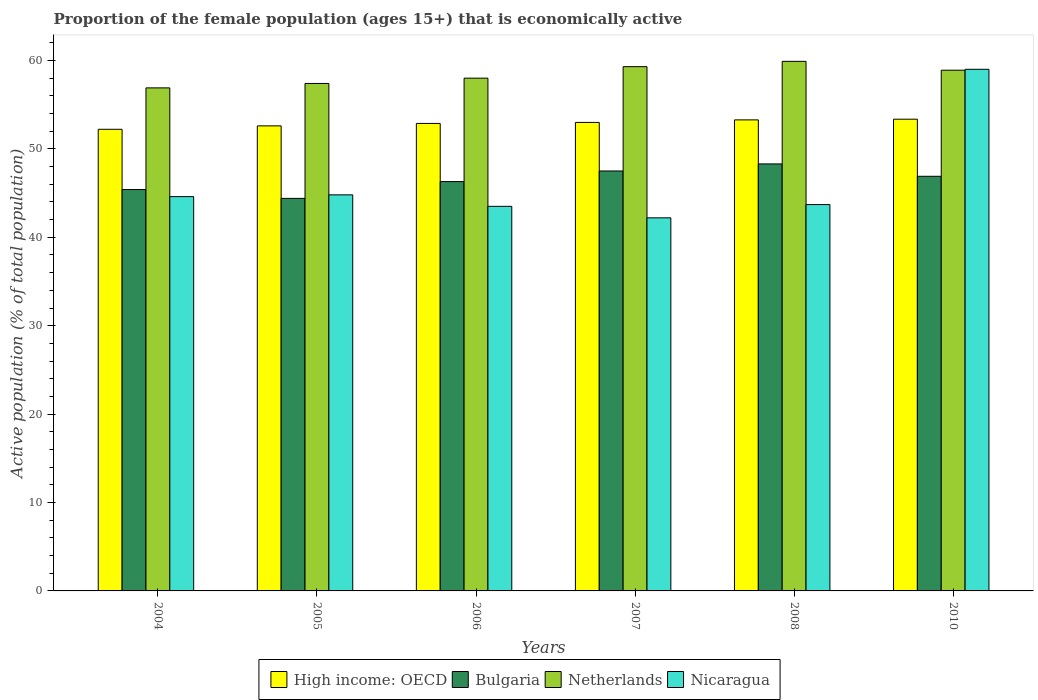How many different coloured bars are there?
Ensure brevity in your answer.  4. How many groups of bars are there?
Ensure brevity in your answer.  6. Are the number of bars per tick equal to the number of legend labels?
Give a very brief answer. Yes. How many bars are there on the 5th tick from the left?
Provide a succinct answer. 4. What is the label of the 5th group of bars from the left?
Your answer should be very brief. 2008. What is the proportion of the female population that is economically active in Nicaragua in 2006?
Offer a very short reply. 43.5. Across all years, what is the maximum proportion of the female population that is economically active in Netherlands?
Offer a very short reply. 59.9. Across all years, what is the minimum proportion of the female population that is economically active in High income: OECD?
Your answer should be very brief. 52.22. In which year was the proportion of the female population that is economically active in High income: OECD minimum?
Your answer should be compact. 2004. What is the total proportion of the female population that is economically active in Bulgaria in the graph?
Provide a succinct answer. 278.8. What is the difference between the proportion of the female population that is economically active in Nicaragua in 2005 and that in 2006?
Ensure brevity in your answer.  1.3. What is the difference between the proportion of the female population that is economically active in Netherlands in 2007 and the proportion of the female population that is economically active in Bulgaria in 2010?
Offer a very short reply. 12.4. What is the average proportion of the female population that is economically active in High income: OECD per year?
Your response must be concise. 52.89. In the year 2007, what is the difference between the proportion of the female population that is economically active in Bulgaria and proportion of the female population that is economically active in Nicaragua?
Offer a terse response. 5.3. What is the ratio of the proportion of the female population that is economically active in Netherlands in 2007 to that in 2008?
Offer a very short reply. 0.99. Is the difference between the proportion of the female population that is economically active in Bulgaria in 2007 and 2010 greater than the difference between the proportion of the female population that is economically active in Nicaragua in 2007 and 2010?
Your answer should be very brief. Yes. What is the difference between the highest and the second highest proportion of the female population that is economically active in Bulgaria?
Provide a succinct answer. 0.8. What is the difference between the highest and the lowest proportion of the female population that is economically active in Netherlands?
Your answer should be very brief. 3. Is it the case that in every year, the sum of the proportion of the female population that is economically active in High income: OECD and proportion of the female population that is economically active in Bulgaria is greater than the sum of proportion of the female population that is economically active in Nicaragua and proportion of the female population that is economically active in Netherlands?
Your answer should be very brief. No. What does the 3rd bar from the right in 2007 represents?
Keep it short and to the point. Bulgaria. Are all the bars in the graph horizontal?
Provide a short and direct response. No. How many years are there in the graph?
Ensure brevity in your answer.  6. What is the difference between two consecutive major ticks on the Y-axis?
Ensure brevity in your answer.  10. Are the values on the major ticks of Y-axis written in scientific E-notation?
Make the answer very short. No. Where does the legend appear in the graph?
Offer a terse response. Bottom center. How are the legend labels stacked?
Provide a succinct answer. Horizontal. What is the title of the graph?
Provide a succinct answer. Proportion of the female population (ages 15+) that is economically active. What is the label or title of the X-axis?
Provide a succinct answer. Years. What is the label or title of the Y-axis?
Your answer should be very brief. Active population (% of total population). What is the Active population (% of total population) of High income: OECD in 2004?
Ensure brevity in your answer.  52.22. What is the Active population (% of total population) of Bulgaria in 2004?
Offer a terse response. 45.4. What is the Active population (% of total population) in Netherlands in 2004?
Your response must be concise. 56.9. What is the Active population (% of total population) of Nicaragua in 2004?
Keep it short and to the point. 44.6. What is the Active population (% of total population) in High income: OECD in 2005?
Ensure brevity in your answer.  52.6. What is the Active population (% of total population) in Bulgaria in 2005?
Ensure brevity in your answer.  44.4. What is the Active population (% of total population) of Netherlands in 2005?
Make the answer very short. 57.4. What is the Active population (% of total population) in Nicaragua in 2005?
Provide a short and direct response. 44.8. What is the Active population (% of total population) of High income: OECD in 2006?
Your response must be concise. 52.88. What is the Active population (% of total population) of Bulgaria in 2006?
Make the answer very short. 46.3. What is the Active population (% of total population) of Nicaragua in 2006?
Your answer should be compact. 43.5. What is the Active population (% of total population) of High income: OECD in 2007?
Give a very brief answer. 52.99. What is the Active population (% of total population) in Bulgaria in 2007?
Your answer should be very brief. 47.5. What is the Active population (% of total population) of Netherlands in 2007?
Make the answer very short. 59.3. What is the Active population (% of total population) in Nicaragua in 2007?
Make the answer very short. 42.2. What is the Active population (% of total population) in High income: OECD in 2008?
Keep it short and to the point. 53.28. What is the Active population (% of total population) of Bulgaria in 2008?
Make the answer very short. 48.3. What is the Active population (% of total population) of Netherlands in 2008?
Your response must be concise. 59.9. What is the Active population (% of total population) in Nicaragua in 2008?
Your answer should be very brief. 43.7. What is the Active population (% of total population) of High income: OECD in 2010?
Ensure brevity in your answer.  53.36. What is the Active population (% of total population) of Bulgaria in 2010?
Your response must be concise. 46.9. What is the Active population (% of total population) in Netherlands in 2010?
Ensure brevity in your answer.  58.9. What is the Active population (% of total population) in Nicaragua in 2010?
Your answer should be compact. 59. Across all years, what is the maximum Active population (% of total population) of High income: OECD?
Ensure brevity in your answer.  53.36. Across all years, what is the maximum Active population (% of total population) in Bulgaria?
Offer a terse response. 48.3. Across all years, what is the maximum Active population (% of total population) in Netherlands?
Your response must be concise. 59.9. Across all years, what is the maximum Active population (% of total population) of Nicaragua?
Your response must be concise. 59. Across all years, what is the minimum Active population (% of total population) in High income: OECD?
Offer a terse response. 52.22. Across all years, what is the minimum Active population (% of total population) of Bulgaria?
Provide a succinct answer. 44.4. Across all years, what is the minimum Active population (% of total population) of Netherlands?
Offer a very short reply. 56.9. Across all years, what is the minimum Active population (% of total population) of Nicaragua?
Your answer should be very brief. 42.2. What is the total Active population (% of total population) of High income: OECD in the graph?
Your answer should be very brief. 317.33. What is the total Active population (% of total population) of Bulgaria in the graph?
Offer a very short reply. 278.8. What is the total Active population (% of total population) in Netherlands in the graph?
Make the answer very short. 350.4. What is the total Active population (% of total population) of Nicaragua in the graph?
Your response must be concise. 277.8. What is the difference between the Active population (% of total population) in High income: OECD in 2004 and that in 2005?
Offer a very short reply. -0.39. What is the difference between the Active population (% of total population) in Netherlands in 2004 and that in 2005?
Give a very brief answer. -0.5. What is the difference between the Active population (% of total population) of Nicaragua in 2004 and that in 2005?
Ensure brevity in your answer.  -0.2. What is the difference between the Active population (% of total population) in High income: OECD in 2004 and that in 2006?
Your answer should be very brief. -0.66. What is the difference between the Active population (% of total population) in Netherlands in 2004 and that in 2006?
Your answer should be compact. -1.1. What is the difference between the Active population (% of total population) in Nicaragua in 2004 and that in 2006?
Your answer should be very brief. 1.1. What is the difference between the Active population (% of total population) of High income: OECD in 2004 and that in 2007?
Your answer should be very brief. -0.78. What is the difference between the Active population (% of total population) in Bulgaria in 2004 and that in 2007?
Ensure brevity in your answer.  -2.1. What is the difference between the Active population (% of total population) of Netherlands in 2004 and that in 2007?
Keep it short and to the point. -2.4. What is the difference between the Active population (% of total population) of Nicaragua in 2004 and that in 2007?
Your response must be concise. 2.4. What is the difference between the Active population (% of total population) of High income: OECD in 2004 and that in 2008?
Your answer should be compact. -1.06. What is the difference between the Active population (% of total population) of Bulgaria in 2004 and that in 2008?
Provide a short and direct response. -2.9. What is the difference between the Active population (% of total population) of High income: OECD in 2004 and that in 2010?
Ensure brevity in your answer.  -1.14. What is the difference between the Active population (% of total population) of Bulgaria in 2004 and that in 2010?
Offer a very short reply. -1.5. What is the difference between the Active population (% of total population) in Netherlands in 2004 and that in 2010?
Offer a very short reply. -2. What is the difference between the Active population (% of total population) of Nicaragua in 2004 and that in 2010?
Ensure brevity in your answer.  -14.4. What is the difference between the Active population (% of total population) of High income: OECD in 2005 and that in 2006?
Offer a very short reply. -0.27. What is the difference between the Active population (% of total population) in Bulgaria in 2005 and that in 2006?
Offer a very short reply. -1.9. What is the difference between the Active population (% of total population) in Netherlands in 2005 and that in 2006?
Ensure brevity in your answer.  -0.6. What is the difference between the Active population (% of total population) in Nicaragua in 2005 and that in 2006?
Ensure brevity in your answer.  1.3. What is the difference between the Active population (% of total population) of High income: OECD in 2005 and that in 2007?
Make the answer very short. -0.39. What is the difference between the Active population (% of total population) in Netherlands in 2005 and that in 2007?
Ensure brevity in your answer.  -1.9. What is the difference between the Active population (% of total population) of High income: OECD in 2005 and that in 2008?
Make the answer very short. -0.68. What is the difference between the Active population (% of total population) of Netherlands in 2005 and that in 2008?
Make the answer very short. -2.5. What is the difference between the Active population (% of total population) in Nicaragua in 2005 and that in 2008?
Provide a succinct answer. 1.1. What is the difference between the Active population (% of total population) of High income: OECD in 2005 and that in 2010?
Give a very brief answer. -0.76. What is the difference between the Active population (% of total population) of Netherlands in 2005 and that in 2010?
Provide a succinct answer. -1.5. What is the difference between the Active population (% of total population) in Nicaragua in 2005 and that in 2010?
Make the answer very short. -14.2. What is the difference between the Active population (% of total population) in High income: OECD in 2006 and that in 2007?
Your answer should be very brief. -0.11. What is the difference between the Active population (% of total population) in Bulgaria in 2006 and that in 2007?
Offer a terse response. -1.2. What is the difference between the Active population (% of total population) of Nicaragua in 2006 and that in 2007?
Provide a short and direct response. 1.3. What is the difference between the Active population (% of total population) of High income: OECD in 2006 and that in 2008?
Keep it short and to the point. -0.4. What is the difference between the Active population (% of total population) of Bulgaria in 2006 and that in 2008?
Your answer should be very brief. -2. What is the difference between the Active population (% of total population) in Nicaragua in 2006 and that in 2008?
Your response must be concise. -0.2. What is the difference between the Active population (% of total population) in High income: OECD in 2006 and that in 2010?
Make the answer very short. -0.48. What is the difference between the Active population (% of total population) in Bulgaria in 2006 and that in 2010?
Offer a very short reply. -0.6. What is the difference between the Active population (% of total population) of Netherlands in 2006 and that in 2010?
Make the answer very short. -0.9. What is the difference between the Active population (% of total population) of Nicaragua in 2006 and that in 2010?
Give a very brief answer. -15.5. What is the difference between the Active population (% of total population) of High income: OECD in 2007 and that in 2008?
Provide a succinct answer. -0.29. What is the difference between the Active population (% of total population) of Netherlands in 2007 and that in 2008?
Your response must be concise. -0.6. What is the difference between the Active population (% of total population) in Nicaragua in 2007 and that in 2008?
Offer a terse response. -1.5. What is the difference between the Active population (% of total population) in High income: OECD in 2007 and that in 2010?
Keep it short and to the point. -0.37. What is the difference between the Active population (% of total population) of Nicaragua in 2007 and that in 2010?
Provide a short and direct response. -16.8. What is the difference between the Active population (% of total population) in High income: OECD in 2008 and that in 2010?
Keep it short and to the point. -0.08. What is the difference between the Active population (% of total population) of Bulgaria in 2008 and that in 2010?
Make the answer very short. 1.4. What is the difference between the Active population (% of total population) of Nicaragua in 2008 and that in 2010?
Make the answer very short. -15.3. What is the difference between the Active population (% of total population) in High income: OECD in 2004 and the Active population (% of total population) in Bulgaria in 2005?
Give a very brief answer. 7.82. What is the difference between the Active population (% of total population) in High income: OECD in 2004 and the Active population (% of total population) in Netherlands in 2005?
Offer a very short reply. -5.18. What is the difference between the Active population (% of total population) of High income: OECD in 2004 and the Active population (% of total population) of Nicaragua in 2005?
Ensure brevity in your answer.  7.42. What is the difference between the Active population (% of total population) in Bulgaria in 2004 and the Active population (% of total population) in Netherlands in 2005?
Ensure brevity in your answer.  -12. What is the difference between the Active population (% of total population) of High income: OECD in 2004 and the Active population (% of total population) of Bulgaria in 2006?
Make the answer very short. 5.92. What is the difference between the Active population (% of total population) of High income: OECD in 2004 and the Active population (% of total population) of Netherlands in 2006?
Give a very brief answer. -5.78. What is the difference between the Active population (% of total population) of High income: OECD in 2004 and the Active population (% of total population) of Nicaragua in 2006?
Make the answer very short. 8.72. What is the difference between the Active population (% of total population) in Bulgaria in 2004 and the Active population (% of total population) in Nicaragua in 2006?
Offer a very short reply. 1.9. What is the difference between the Active population (% of total population) in High income: OECD in 2004 and the Active population (% of total population) in Bulgaria in 2007?
Provide a short and direct response. 4.72. What is the difference between the Active population (% of total population) of High income: OECD in 2004 and the Active population (% of total population) of Netherlands in 2007?
Make the answer very short. -7.08. What is the difference between the Active population (% of total population) in High income: OECD in 2004 and the Active population (% of total population) in Nicaragua in 2007?
Offer a very short reply. 10.02. What is the difference between the Active population (% of total population) of Bulgaria in 2004 and the Active population (% of total population) of Nicaragua in 2007?
Your answer should be compact. 3.2. What is the difference between the Active population (% of total population) in High income: OECD in 2004 and the Active population (% of total population) in Bulgaria in 2008?
Your answer should be very brief. 3.92. What is the difference between the Active population (% of total population) of High income: OECD in 2004 and the Active population (% of total population) of Netherlands in 2008?
Make the answer very short. -7.68. What is the difference between the Active population (% of total population) of High income: OECD in 2004 and the Active population (% of total population) of Nicaragua in 2008?
Give a very brief answer. 8.52. What is the difference between the Active population (% of total population) in High income: OECD in 2004 and the Active population (% of total population) in Bulgaria in 2010?
Give a very brief answer. 5.32. What is the difference between the Active population (% of total population) of High income: OECD in 2004 and the Active population (% of total population) of Netherlands in 2010?
Your answer should be very brief. -6.68. What is the difference between the Active population (% of total population) in High income: OECD in 2004 and the Active population (% of total population) in Nicaragua in 2010?
Ensure brevity in your answer.  -6.78. What is the difference between the Active population (% of total population) in Bulgaria in 2004 and the Active population (% of total population) in Nicaragua in 2010?
Provide a short and direct response. -13.6. What is the difference between the Active population (% of total population) in High income: OECD in 2005 and the Active population (% of total population) in Bulgaria in 2006?
Your answer should be very brief. 6.3. What is the difference between the Active population (% of total population) of High income: OECD in 2005 and the Active population (% of total population) of Netherlands in 2006?
Give a very brief answer. -5.4. What is the difference between the Active population (% of total population) of High income: OECD in 2005 and the Active population (% of total population) of Nicaragua in 2006?
Your answer should be compact. 9.1. What is the difference between the Active population (% of total population) in Bulgaria in 2005 and the Active population (% of total population) in Netherlands in 2006?
Keep it short and to the point. -13.6. What is the difference between the Active population (% of total population) of Bulgaria in 2005 and the Active population (% of total population) of Nicaragua in 2006?
Offer a terse response. 0.9. What is the difference between the Active population (% of total population) in High income: OECD in 2005 and the Active population (% of total population) in Bulgaria in 2007?
Provide a succinct answer. 5.1. What is the difference between the Active population (% of total population) in High income: OECD in 2005 and the Active population (% of total population) in Netherlands in 2007?
Keep it short and to the point. -6.7. What is the difference between the Active population (% of total population) of High income: OECD in 2005 and the Active population (% of total population) of Nicaragua in 2007?
Offer a very short reply. 10.4. What is the difference between the Active population (% of total population) in Bulgaria in 2005 and the Active population (% of total population) in Netherlands in 2007?
Give a very brief answer. -14.9. What is the difference between the Active population (% of total population) in Bulgaria in 2005 and the Active population (% of total population) in Nicaragua in 2007?
Provide a succinct answer. 2.2. What is the difference between the Active population (% of total population) of High income: OECD in 2005 and the Active population (% of total population) of Bulgaria in 2008?
Your answer should be compact. 4.3. What is the difference between the Active population (% of total population) of High income: OECD in 2005 and the Active population (% of total population) of Netherlands in 2008?
Your response must be concise. -7.3. What is the difference between the Active population (% of total population) of High income: OECD in 2005 and the Active population (% of total population) of Nicaragua in 2008?
Offer a very short reply. 8.9. What is the difference between the Active population (% of total population) of Bulgaria in 2005 and the Active population (% of total population) of Netherlands in 2008?
Your answer should be very brief. -15.5. What is the difference between the Active population (% of total population) in Netherlands in 2005 and the Active population (% of total population) in Nicaragua in 2008?
Keep it short and to the point. 13.7. What is the difference between the Active population (% of total population) of High income: OECD in 2005 and the Active population (% of total population) of Bulgaria in 2010?
Give a very brief answer. 5.7. What is the difference between the Active population (% of total population) in High income: OECD in 2005 and the Active population (% of total population) in Netherlands in 2010?
Keep it short and to the point. -6.3. What is the difference between the Active population (% of total population) of High income: OECD in 2005 and the Active population (% of total population) of Nicaragua in 2010?
Keep it short and to the point. -6.4. What is the difference between the Active population (% of total population) of Bulgaria in 2005 and the Active population (% of total population) of Nicaragua in 2010?
Your response must be concise. -14.6. What is the difference between the Active population (% of total population) in High income: OECD in 2006 and the Active population (% of total population) in Bulgaria in 2007?
Your answer should be compact. 5.38. What is the difference between the Active population (% of total population) in High income: OECD in 2006 and the Active population (% of total population) in Netherlands in 2007?
Your answer should be compact. -6.42. What is the difference between the Active population (% of total population) of High income: OECD in 2006 and the Active population (% of total population) of Nicaragua in 2007?
Provide a short and direct response. 10.68. What is the difference between the Active population (% of total population) in Bulgaria in 2006 and the Active population (% of total population) in Nicaragua in 2007?
Offer a very short reply. 4.1. What is the difference between the Active population (% of total population) in Netherlands in 2006 and the Active population (% of total population) in Nicaragua in 2007?
Your answer should be very brief. 15.8. What is the difference between the Active population (% of total population) in High income: OECD in 2006 and the Active population (% of total population) in Bulgaria in 2008?
Provide a short and direct response. 4.58. What is the difference between the Active population (% of total population) in High income: OECD in 2006 and the Active population (% of total population) in Netherlands in 2008?
Your response must be concise. -7.02. What is the difference between the Active population (% of total population) of High income: OECD in 2006 and the Active population (% of total population) of Nicaragua in 2008?
Offer a very short reply. 9.18. What is the difference between the Active population (% of total population) of Bulgaria in 2006 and the Active population (% of total population) of Netherlands in 2008?
Provide a succinct answer. -13.6. What is the difference between the Active population (% of total population) in Bulgaria in 2006 and the Active population (% of total population) in Nicaragua in 2008?
Your answer should be compact. 2.6. What is the difference between the Active population (% of total population) of High income: OECD in 2006 and the Active population (% of total population) of Bulgaria in 2010?
Keep it short and to the point. 5.98. What is the difference between the Active population (% of total population) in High income: OECD in 2006 and the Active population (% of total population) in Netherlands in 2010?
Your response must be concise. -6.02. What is the difference between the Active population (% of total population) of High income: OECD in 2006 and the Active population (% of total population) of Nicaragua in 2010?
Ensure brevity in your answer.  -6.12. What is the difference between the Active population (% of total population) of Bulgaria in 2006 and the Active population (% of total population) of Netherlands in 2010?
Give a very brief answer. -12.6. What is the difference between the Active population (% of total population) in Netherlands in 2006 and the Active population (% of total population) in Nicaragua in 2010?
Your answer should be compact. -1. What is the difference between the Active population (% of total population) of High income: OECD in 2007 and the Active population (% of total population) of Bulgaria in 2008?
Keep it short and to the point. 4.69. What is the difference between the Active population (% of total population) of High income: OECD in 2007 and the Active population (% of total population) of Netherlands in 2008?
Provide a short and direct response. -6.91. What is the difference between the Active population (% of total population) in High income: OECD in 2007 and the Active population (% of total population) in Nicaragua in 2008?
Offer a terse response. 9.29. What is the difference between the Active population (% of total population) in Bulgaria in 2007 and the Active population (% of total population) in Nicaragua in 2008?
Offer a terse response. 3.8. What is the difference between the Active population (% of total population) of High income: OECD in 2007 and the Active population (% of total population) of Bulgaria in 2010?
Make the answer very short. 6.09. What is the difference between the Active population (% of total population) in High income: OECD in 2007 and the Active population (% of total population) in Netherlands in 2010?
Ensure brevity in your answer.  -5.91. What is the difference between the Active population (% of total population) of High income: OECD in 2007 and the Active population (% of total population) of Nicaragua in 2010?
Keep it short and to the point. -6.01. What is the difference between the Active population (% of total population) of Netherlands in 2007 and the Active population (% of total population) of Nicaragua in 2010?
Offer a very short reply. 0.3. What is the difference between the Active population (% of total population) of High income: OECD in 2008 and the Active population (% of total population) of Bulgaria in 2010?
Provide a short and direct response. 6.38. What is the difference between the Active population (% of total population) in High income: OECD in 2008 and the Active population (% of total population) in Netherlands in 2010?
Offer a very short reply. -5.62. What is the difference between the Active population (% of total population) in High income: OECD in 2008 and the Active population (% of total population) in Nicaragua in 2010?
Offer a very short reply. -5.72. What is the difference between the Active population (% of total population) in Bulgaria in 2008 and the Active population (% of total population) in Nicaragua in 2010?
Provide a short and direct response. -10.7. What is the difference between the Active population (% of total population) of Netherlands in 2008 and the Active population (% of total population) of Nicaragua in 2010?
Your answer should be very brief. 0.9. What is the average Active population (% of total population) in High income: OECD per year?
Your answer should be compact. 52.89. What is the average Active population (% of total population) in Bulgaria per year?
Give a very brief answer. 46.47. What is the average Active population (% of total population) of Netherlands per year?
Make the answer very short. 58.4. What is the average Active population (% of total population) of Nicaragua per year?
Offer a terse response. 46.3. In the year 2004, what is the difference between the Active population (% of total population) in High income: OECD and Active population (% of total population) in Bulgaria?
Ensure brevity in your answer.  6.82. In the year 2004, what is the difference between the Active population (% of total population) in High income: OECD and Active population (% of total population) in Netherlands?
Provide a succinct answer. -4.68. In the year 2004, what is the difference between the Active population (% of total population) of High income: OECD and Active population (% of total population) of Nicaragua?
Provide a succinct answer. 7.62. In the year 2004, what is the difference between the Active population (% of total population) in Bulgaria and Active population (% of total population) in Nicaragua?
Offer a terse response. 0.8. In the year 2004, what is the difference between the Active population (% of total population) of Netherlands and Active population (% of total population) of Nicaragua?
Give a very brief answer. 12.3. In the year 2005, what is the difference between the Active population (% of total population) of High income: OECD and Active population (% of total population) of Bulgaria?
Keep it short and to the point. 8.2. In the year 2005, what is the difference between the Active population (% of total population) in High income: OECD and Active population (% of total population) in Netherlands?
Provide a short and direct response. -4.8. In the year 2005, what is the difference between the Active population (% of total population) in High income: OECD and Active population (% of total population) in Nicaragua?
Ensure brevity in your answer.  7.8. In the year 2005, what is the difference between the Active population (% of total population) in Bulgaria and Active population (% of total population) in Netherlands?
Make the answer very short. -13. In the year 2005, what is the difference between the Active population (% of total population) in Netherlands and Active population (% of total population) in Nicaragua?
Offer a very short reply. 12.6. In the year 2006, what is the difference between the Active population (% of total population) in High income: OECD and Active population (% of total population) in Bulgaria?
Provide a short and direct response. 6.58. In the year 2006, what is the difference between the Active population (% of total population) in High income: OECD and Active population (% of total population) in Netherlands?
Offer a terse response. -5.12. In the year 2006, what is the difference between the Active population (% of total population) of High income: OECD and Active population (% of total population) of Nicaragua?
Offer a very short reply. 9.38. In the year 2006, what is the difference between the Active population (% of total population) of Bulgaria and Active population (% of total population) of Nicaragua?
Offer a terse response. 2.8. In the year 2007, what is the difference between the Active population (% of total population) of High income: OECD and Active population (% of total population) of Bulgaria?
Make the answer very short. 5.49. In the year 2007, what is the difference between the Active population (% of total population) in High income: OECD and Active population (% of total population) in Netherlands?
Provide a short and direct response. -6.31. In the year 2007, what is the difference between the Active population (% of total population) of High income: OECD and Active population (% of total population) of Nicaragua?
Provide a succinct answer. 10.79. In the year 2007, what is the difference between the Active population (% of total population) of Bulgaria and Active population (% of total population) of Nicaragua?
Your answer should be very brief. 5.3. In the year 2008, what is the difference between the Active population (% of total population) of High income: OECD and Active population (% of total population) of Bulgaria?
Make the answer very short. 4.98. In the year 2008, what is the difference between the Active population (% of total population) in High income: OECD and Active population (% of total population) in Netherlands?
Your answer should be very brief. -6.62. In the year 2008, what is the difference between the Active population (% of total population) of High income: OECD and Active population (% of total population) of Nicaragua?
Offer a terse response. 9.58. In the year 2008, what is the difference between the Active population (% of total population) of Netherlands and Active population (% of total population) of Nicaragua?
Keep it short and to the point. 16.2. In the year 2010, what is the difference between the Active population (% of total population) of High income: OECD and Active population (% of total population) of Bulgaria?
Keep it short and to the point. 6.46. In the year 2010, what is the difference between the Active population (% of total population) of High income: OECD and Active population (% of total population) of Netherlands?
Your response must be concise. -5.54. In the year 2010, what is the difference between the Active population (% of total population) in High income: OECD and Active population (% of total population) in Nicaragua?
Provide a succinct answer. -5.64. In the year 2010, what is the difference between the Active population (% of total population) in Bulgaria and Active population (% of total population) in Netherlands?
Your response must be concise. -12. What is the ratio of the Active population (% of total population) of Bulgaria in 2004 to that in 2005?
Offer a very short reply. 1.02. What is the ratio of the Active population (% of total population) of Netherlands in 2004 to that in 2005?
Your answer should be compact. 0.99. What is the ratio of the Active population (% of total population) in High income: OECD in 2004 to that in 2006?
Offer a very short reply. 0.99. What is the ratio of the Active population (% of total population) of Bulgaria in 2004 to that in 2006?
Ensure brevity in your answer.  0.98. What is the ratio of the Active population (% of total population) in Netherlands in 2004 to that in 2006?
Keep it short and to the point. 0.98. What is the ratio of the Active population (% of total population) in Nicaragua in 2004 to that in 2006?
Your answer should be very brief. 1.03. What is the ratio of the Active population (% of total population) of High income: OECD in 2004 to that in 2007?
Ensure brevity in your answer.  0.99. What is the ratio of the Active population (% of total population) in Bulgaria in 2004 to that in 2007?
Your response must be concise. 0.96. What is the ratio of the Active population (% of total population) in Netherlands in 2004 to that in 2007?
Your response must be concise. 0.96. What is the ratio of the Active population (% of total population) of Nicaragua in 2004 to that in 2007?
Give a very brief answer. 1.06. What is the ratio of the Active population (% of total population) in High income: OECD in 2004 to that in 2008?
Provide a succinct answer. 0.98. What is the ratio of the Active population (% of total population) of Bulgaria in 2004 to that in 2008?
Provide a succinct answer. 0.94. What is the ratio of the Active population (% of total population) in Netherlands in 2004 to that in 2008?
Keep it short and to the point. 0.95. What is the ratio of the Active population (% of total population) in Nicaragua in 2004 to that in 2008?
Provide a succinct answer. 1.02. What is the ratio of the Active population (% of total population) in High income: OECD in 2004 to that in 2010?
Your answer should be compact. 0.98. What is the ratio of the Active population (% of total population) in Bulgaria in 2004 to that in 2010?
Your answer should be compact. 0.97. What is the ratio of the Active population (% of total population) of Netherlands in 2004 to that in 2010?
Make the answer very short. 0.97. What is the ratio of the Active population (% of total population) in Nicaragua in 2004 to that in 2010?
Your answer should be compact. 0.76. What is the ratio of the Active population (% of total population) in High income: OECD in 2005 to that in 2006?
Keep it short and to the point. 0.99. What is the ratio of the Active population (% of total population) of Bulgaria in 2005 to that in 2006?
Your response must be concise. 0.96. What is the ratio of the Active population (% of total population) in Nicaragua in 2005 to that in 2006?
Offer a terse response. 1.03. What is the ratio of the Active population (% of total population) of High income: OECD in 2005 to that in 2007?
Offer a terse response. 0.99. What is the ratio of the Active population (% of total population) of Bulgaria in 2005 to that in 2007?
Your answer should be compact. 0.93. What is the ratio of the Active population (% of total population) of Nicaragua in 2005 to that in 2007?
Offer a terse response. 1.06. What is the ratio of the Active population (% of total population) of High income: OECD in 2005 to that in 2008?
Make the answer very short. 0.99. What is the ratio of the Active population (% of total population) of Bulgaria in 2005 to that in 2008?
Your answer should be very brief. 0.92. What is the ratio of the Active population (% of total population) of Nicaragua in 2005 to that in 2008?
Make the answer very short. 1.03. What is the ratio of the Active population (% of total population) in High income: OECD in 2005 to that in 2010?
Keep it short and to the point. 0.99. What is the ratio of the Active population (% of total population) of Bulgaria in 2005 to that in 2010?
Offer a very short reply. 0.95. What is the ratio of the Active population (% of total population) of Netherlands in 2005 to that in 2010?
Your response must be concise. 0.97. What is the ratio of the Active population (% of total population) of Nicaragua in 2005 to that in 2010?
Give a very brief answer. 0.76. What is the ratio of the Active population (% of total population) of High income: OECD in 2006 to that in 2007?
Keep it short and to the point. 1. What is the ratio of the Active population (% of total population) of Bulgaria in 2006 to that in 2007?
Offer a terse response. 0.97. What is the ratio of the Active population (% of total population) in Netherlands in 2006 to that in 2007?
Provide a short and direct response. 0.98. What is the ratio of the Active population (% of total population) in Nicaragua in 2006 to that in 2007?
Ensure brevity in your answer.  1.03. What is the ratio of the Active population (% of total population) in High income: OECD in 2006 to that in 2008?
Offer a terse response. 0.99. What is the ratio of the Active population (% of total population) of Bulgaria in 2006 to that in 2008?
Give a very brief answer. 0.96. What is the ratio of the Active population (% of total population) in Netherlands in 2006 to that in 2008?
Make the answer very short. 0.97. What is the ratio of the Active population (% of total population) of Nicaragua in 2006 to that in 2008?
Give a very brief answer. 1. What is the ratio of the Active population (% of total population) in High income: OECD in 2006 to that in 2010?
Your answer should be very brief. 0.99. What is the ratio of the Active population (% of total population) in Bulgaria in 2006 to that in 2010?
Provide a succinct answer. 0.99. What is the ratio of the Active population (% of total population) of Netherlands in 2006 to that in 2010?
Give a very brief answer. 0.98. What is the ratio of the Active population (% of total population) in Nicaragua in 2006 to that in 2010?
Ensure brevity in your answer.  0.74. What is the ratio of the Active population (% of total population) in Bulgaria in 2007 to that in 2008?
Your answer should be very brief. 0.98. What is the ratio of the Active population (% of total population) in Nicaragua in 2007 to that in 2008?
Offer a terse response. 0.97. What is the ratio of the Active population (% of total population) of Bulgaria in 2007 to that in 2010?
Your answer should be very brief. 1.01. What is the ratio of the Active population (% of total population) in Netherlands in 2007 to that in 2010?
Make the answer very short. 1.01. What is the ratio of the Active population (% of total population) of Nicaragua in 2007 to that in 2010?
Keep it short and to the point. 0.72. What is the ratio of the Active population (% of total population) of High income: OECD in 2008 to that in 2010?
Provide a short and direct response. 1. What is the ratio of the Active population (% of total population) in Bulgaria in 2008 to that in 2010?
Your response must be concise. 1.03. What is the ratio of the Active population (% of total population) in Netherlands in 2008 to that in 2010?
Provide a succinct answer. 1.02. What is the ratio of the Active population (% of total population) in Nicaragua in 2008 to that in 2010?
Your response must be concise. 0.74. What is the difference between the highest and the second highest Active population (% of total population) of High income: OECD?
Ensure brevity in your answer.  0.08. What is the difference between the highest and the second highest Active population (% of total population) of Bulgaria?
Ensure brevity in your answer.  0.8. What is the difference between the highest and the second highest Active population (% of total population) of Netherlands?
Make the answer very short. 0.6. What is the difference between the highest and the lowest Active population (% of total population) in High income: OECD?
Ensure brevity in your answer.  1.14. What is the difference between the highest and the lowest Active population (% of total population) of Bulgaria?
Ensure brevity in your answer.  3.9. What is the difference between the highest and the lowest Active population (% of total population) of Netherlands?
Offer a very short reply. 3. 